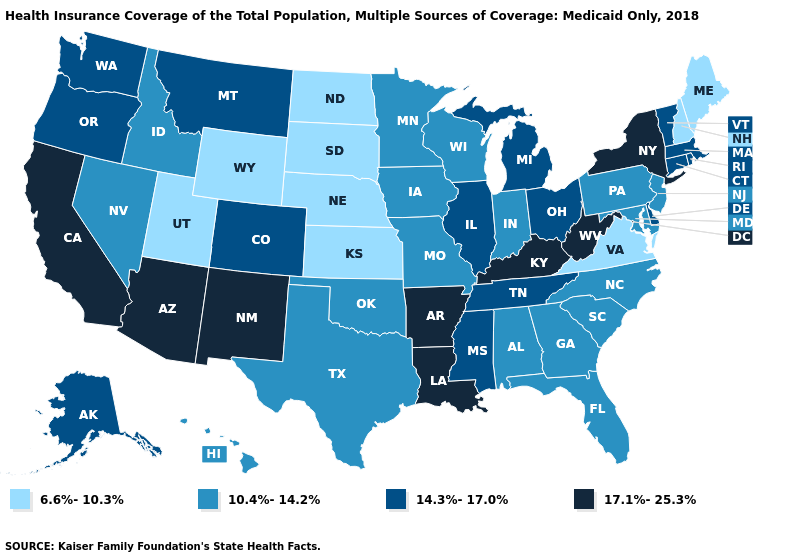Does North Carolina have the lowest value in the USA?
Be succinct. No. What is the value of Arizona?
Quick response, please. 17.1%-25.3%. Among the states that border Washington , which have the lowest value?
Quick response, please. Idaho. Does Delaware have the lowest value in the USA?
Concise answer only. No. Does Florida have the lowest value in the South?
Be succinct. No. What is the value of Florida?
Concise answer only. 10.4%-14.2%. Name the states that have a value in the range 17.1%-25.3%?
Short answer required. Arizona, Arkansas, California, Kentucky, Louisiana, New Mexico, New York, West Virginia. Is the legend a continuous bar?
Give a very brief answer. No. What is the highest value in the USA?
Write a very short answer. 17.1%-25.3%. Does New Mexico have the lowest value in the USA?
Be succinct. No. What is the value of Alaska?
Concise answer only. 14.3%-17.0%. Name the states that have a value in the range 10.4%-14.2%?
Be succinct. Alabama, Florida, Georgia, Hawaii, Idaho, Indiana, Iowa, Maryland, Minnesota, Missouri, Nevada, New Jersey, North Carolina, Oklahoma, Pennsylvania, South Carolina, Texas, Wisconsin. Name the states that have a value in the range 17.1%-25.3%?
Give a very brief answer. Arizona, Arkansas, California, Kentucky, Louisiana, New Mexico, New York, West Virginia. Does the first symbol in the legend represent the smallest category?
Short answer required. Yes. What is the value of Montana?
Write a very short answer. 14.3%-17.0%. 